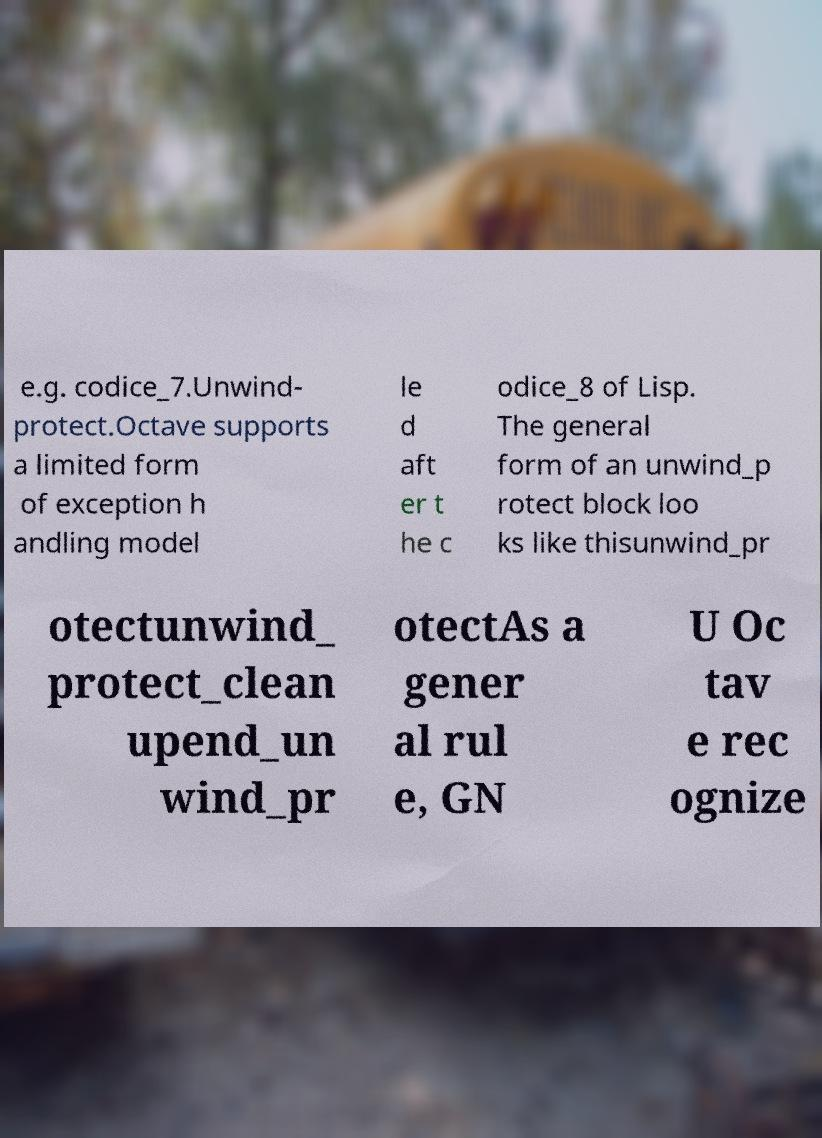Could you extract and type out the text from this image? e.g. codice_7.Unwind- protect.Octave supports a limited form of exception h andling model le d aft er t he c odice_8 of Lisp. The general form of an unwind_p rotect block loo ks like thisunwind_pr otectunwind_ protect_clean upend_un wind_pr otectAs a gener al rul e, GN U Oc tav e rec ognize 